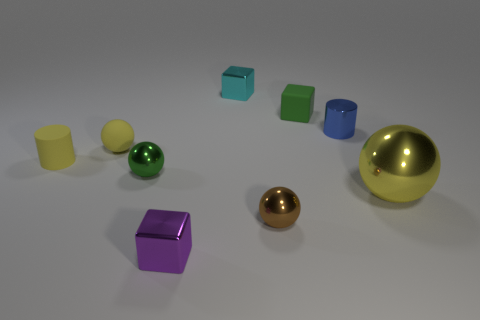What shape is the metal object that is the same color as the rubber block?
Offer a very short reply. Sphere. What is the size of the cylinder that is the same color as the large shiny object?
Provide a succinct answer. Small. Is there another small green metallic object that has the same shape as the green metallic object?
Give a very brief answer. No. What size is the metal block behind the metal cube in front of the yellow sphere that is right of the tiny cyan cube?
Make the answer very short. Small. Is the number of tiny rubber balls in front of the tiny green rubber thing the same as the number of blue metallic objects in front of the blue metal thing?
Provide a succinct answer. No. There is a green ball that is the same material as the blue cylinder; what size is it?
Provide a short and direct response. Small. The big metal sphere is what color?
Ensure brevity in your answer.  Yellow. How many small metallic spheres are the same color as the rubber cube?
Your answer should be compact. 1. What is the material of the yellow sphere that is the same size as the green matte thing?
Give a very brief answer. Rubber. Are there any small purple metal cubes to the right of the shiny block that is in front of the blue cylinder?
Give a very brief answer. No. 